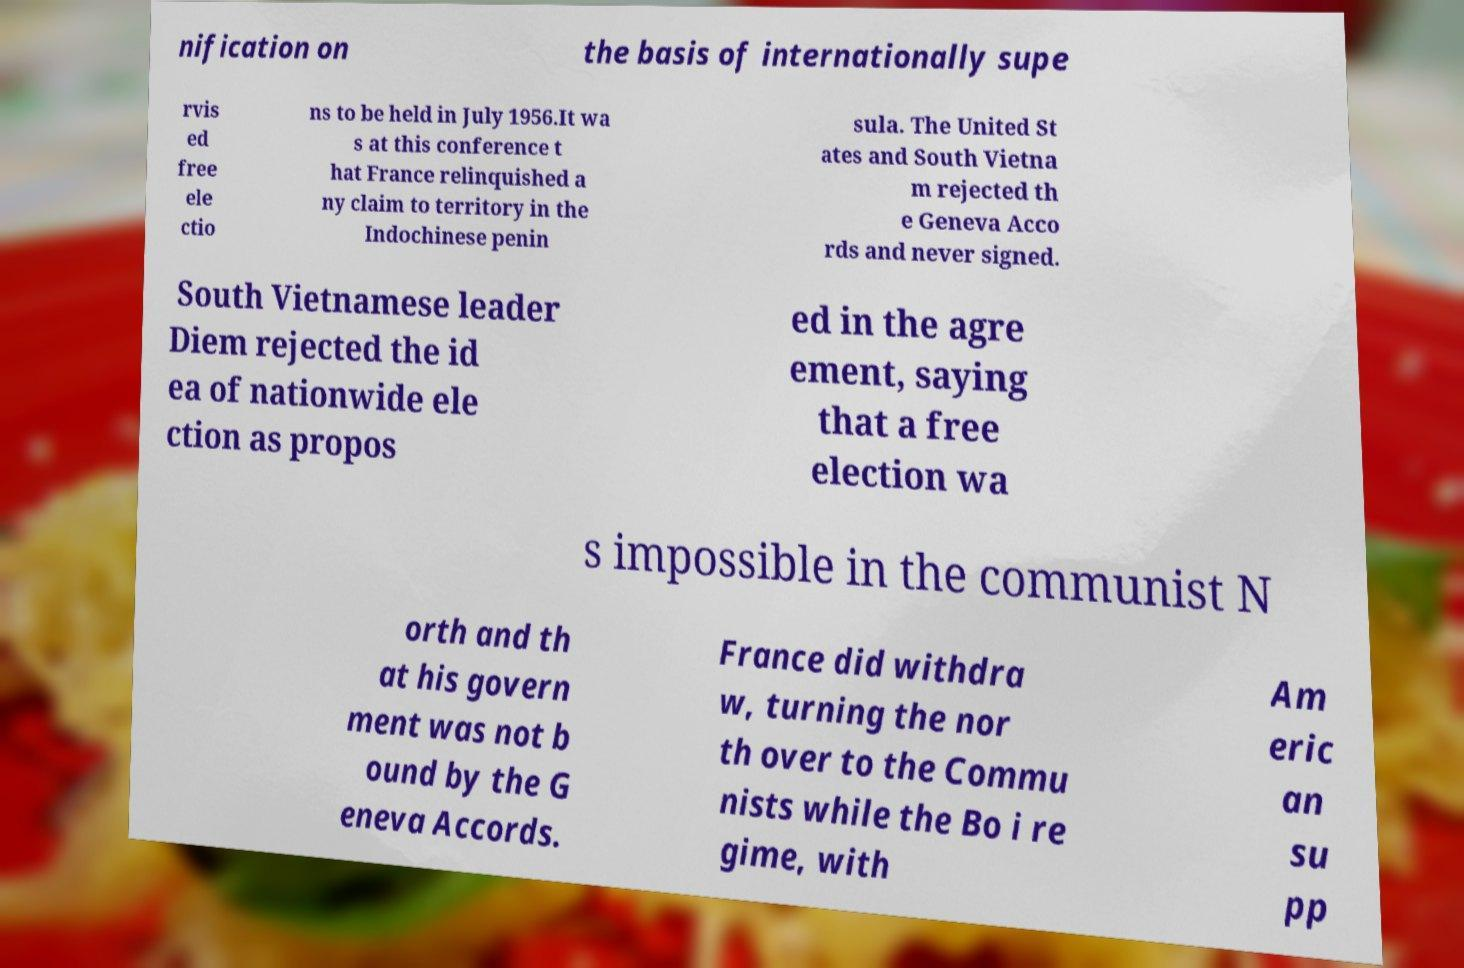I need the written content from this picture converted into text. Can you do that? nification on the basis of internationally supe rvis ed free ele ctio ns to be held in July 1956.It wa s at this conference t hat France relinquished a ny claim to territory in the Indochinese penin sula. The United St ates and South Vietna m rejected th e Geneva Acco rds and never signed. South Vietnamese leader Diem rejected the id ea of nationwide ele ction as propos ed in the agre ement, saying that a free election wa s impossible in the communist N orth and th at his govern ment was not b ound by the G eneva Accords. France did withdra w, turning the nor th over to the Commu nists while the Bo i re gime, with Am eric an su pp 